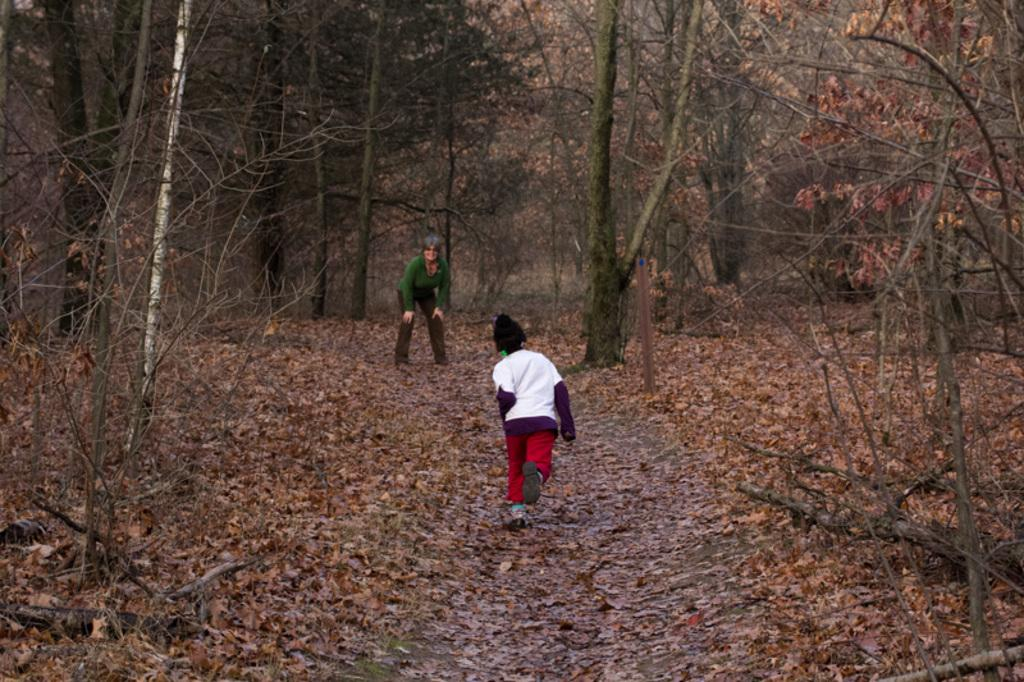What type of natural material can be seen in the image? There are dried leaves in the image. Are there any living beings present in the image? Yes, there are people in the image. What type of vegetation is visible in the image? There are trees in the image. What type of board can be seen in the image? There is no board present in the image. What does the image smell like? The image does not have a smell, as it is a visual representation. 